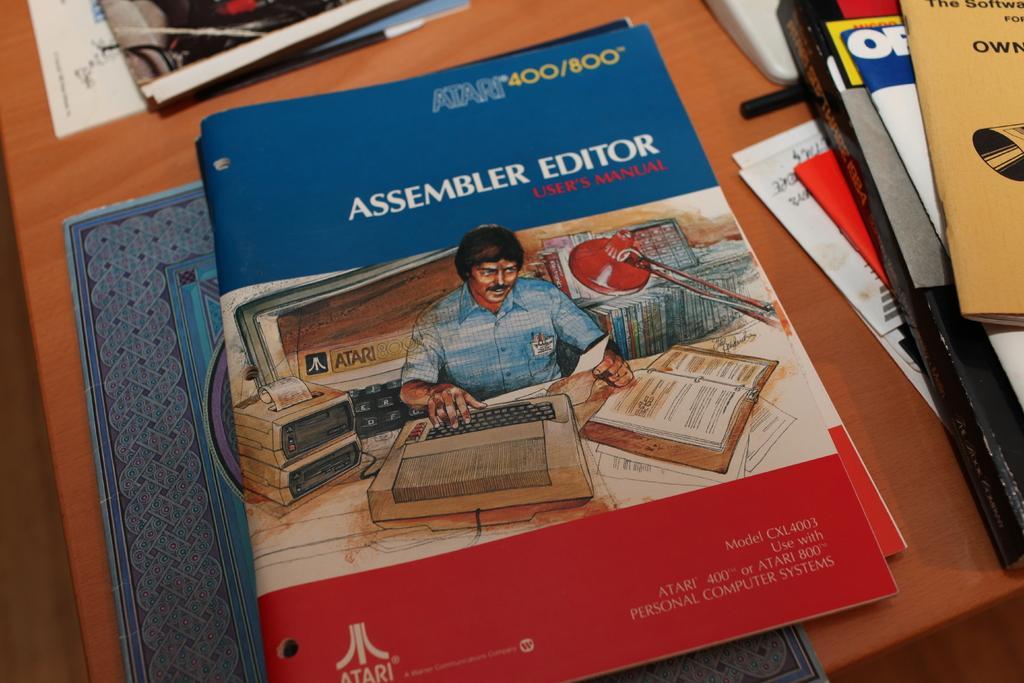How would you summarize this image in a sentence or two? In this image we can see books on the table, here are the papers on it. 